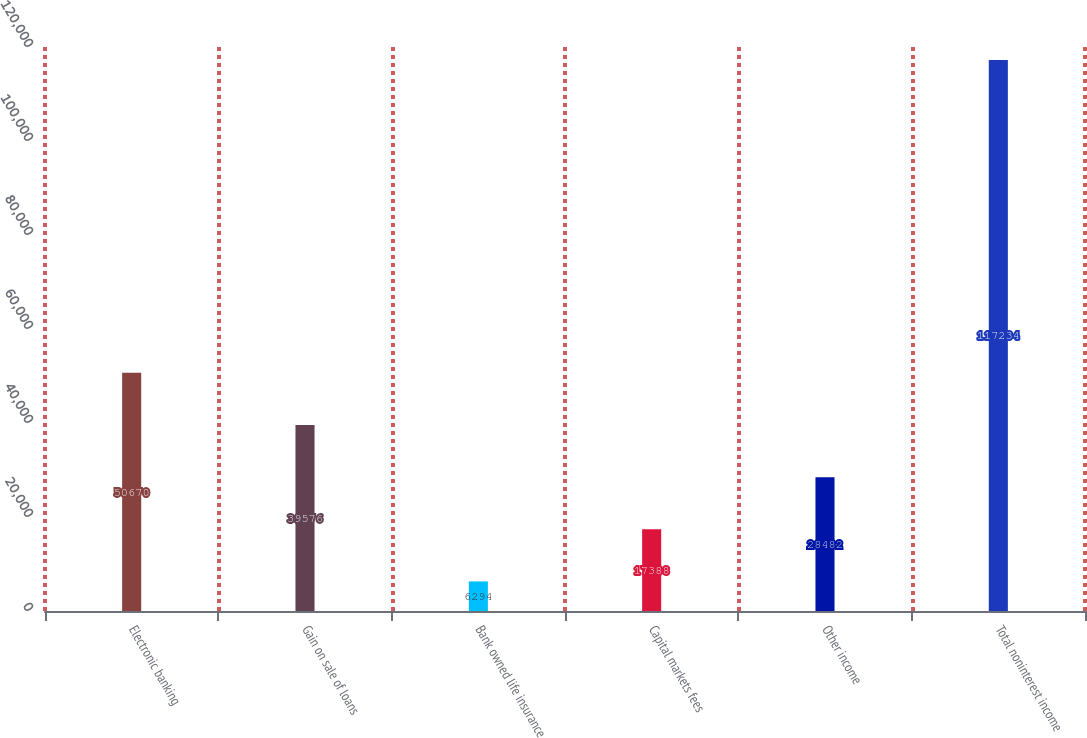Convert chart. <chart><loc_0><loc_0><loc_500><loc_500><bar_chart><fcel>Electronic banking<fcel>Gain on sale of loans<fcel>Bank owned life insurance<fcel>Capital markets fees<fcel>Other income<fcel>Total noninterest income<nl><fcel>50670<fcel>39576<fcel>6294<fcel>17388<fcel>28482<fcel>117234<nl></chart> 